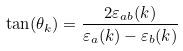Convert formula to latex. <formula><loc_0><loc_0><loc_500><loc_500>\tan ( \theta _ { k } ) = \frac { 2 \varepsilon _ { a b } ( k ) } { \varepsilon _ { a } ( k ) - \varepsilon _ { b } ( k ) }</formula> 